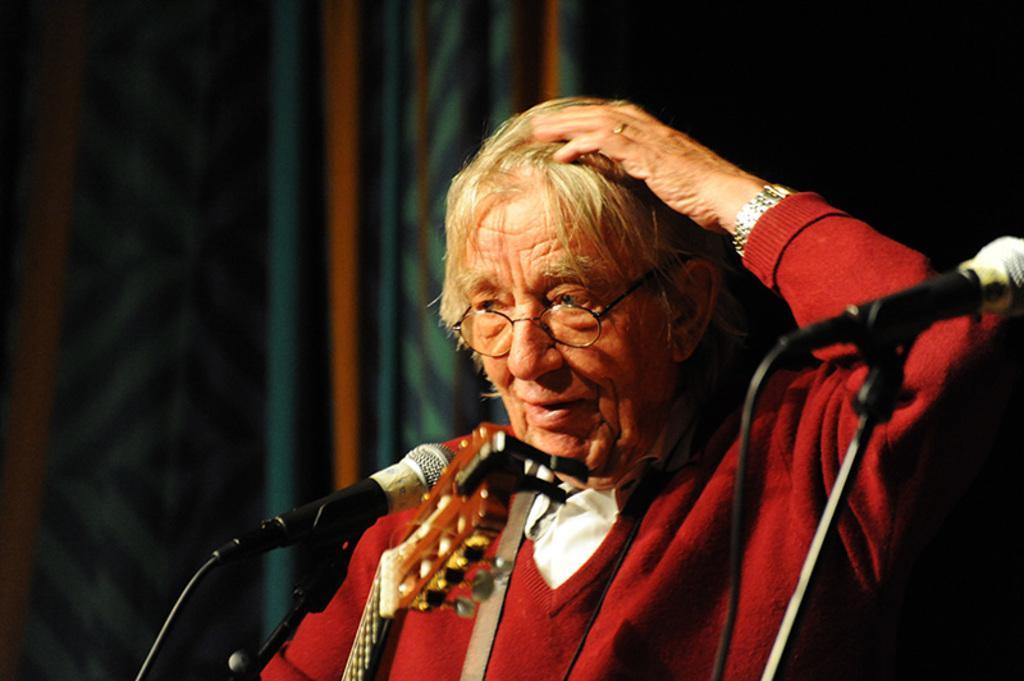Describe this image in one or two sentences. In this image, I can see a person with spectacles. There are miles with the mike stands. At the bottom of the image, I can see a musical instrument. The background is blurry. 